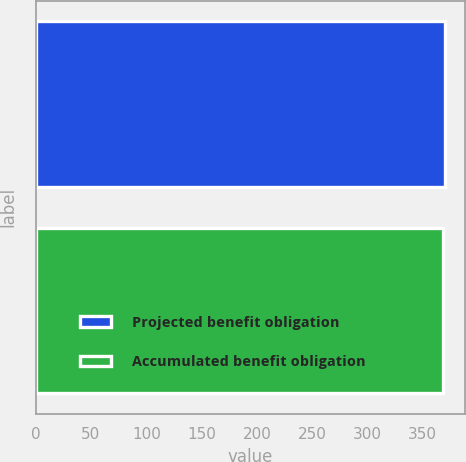<chart> <loc_0><loc_0><loc_500><loc_500><bar_chart><fcel>Projected benefit obligation<fcel>Accumulated benefit obligation<nl><fcel>370<fcel>368<nl></chart> 